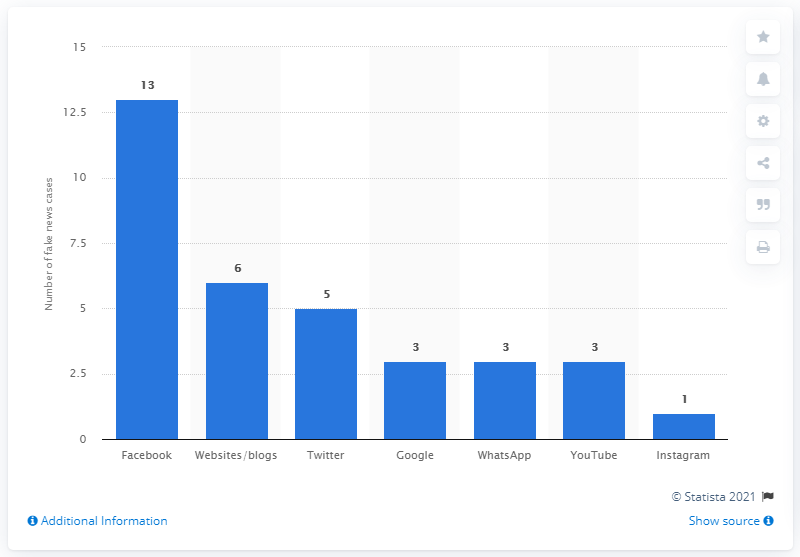Specify some key components in this picture. Facebook is the most popular social network where fake news is published. 